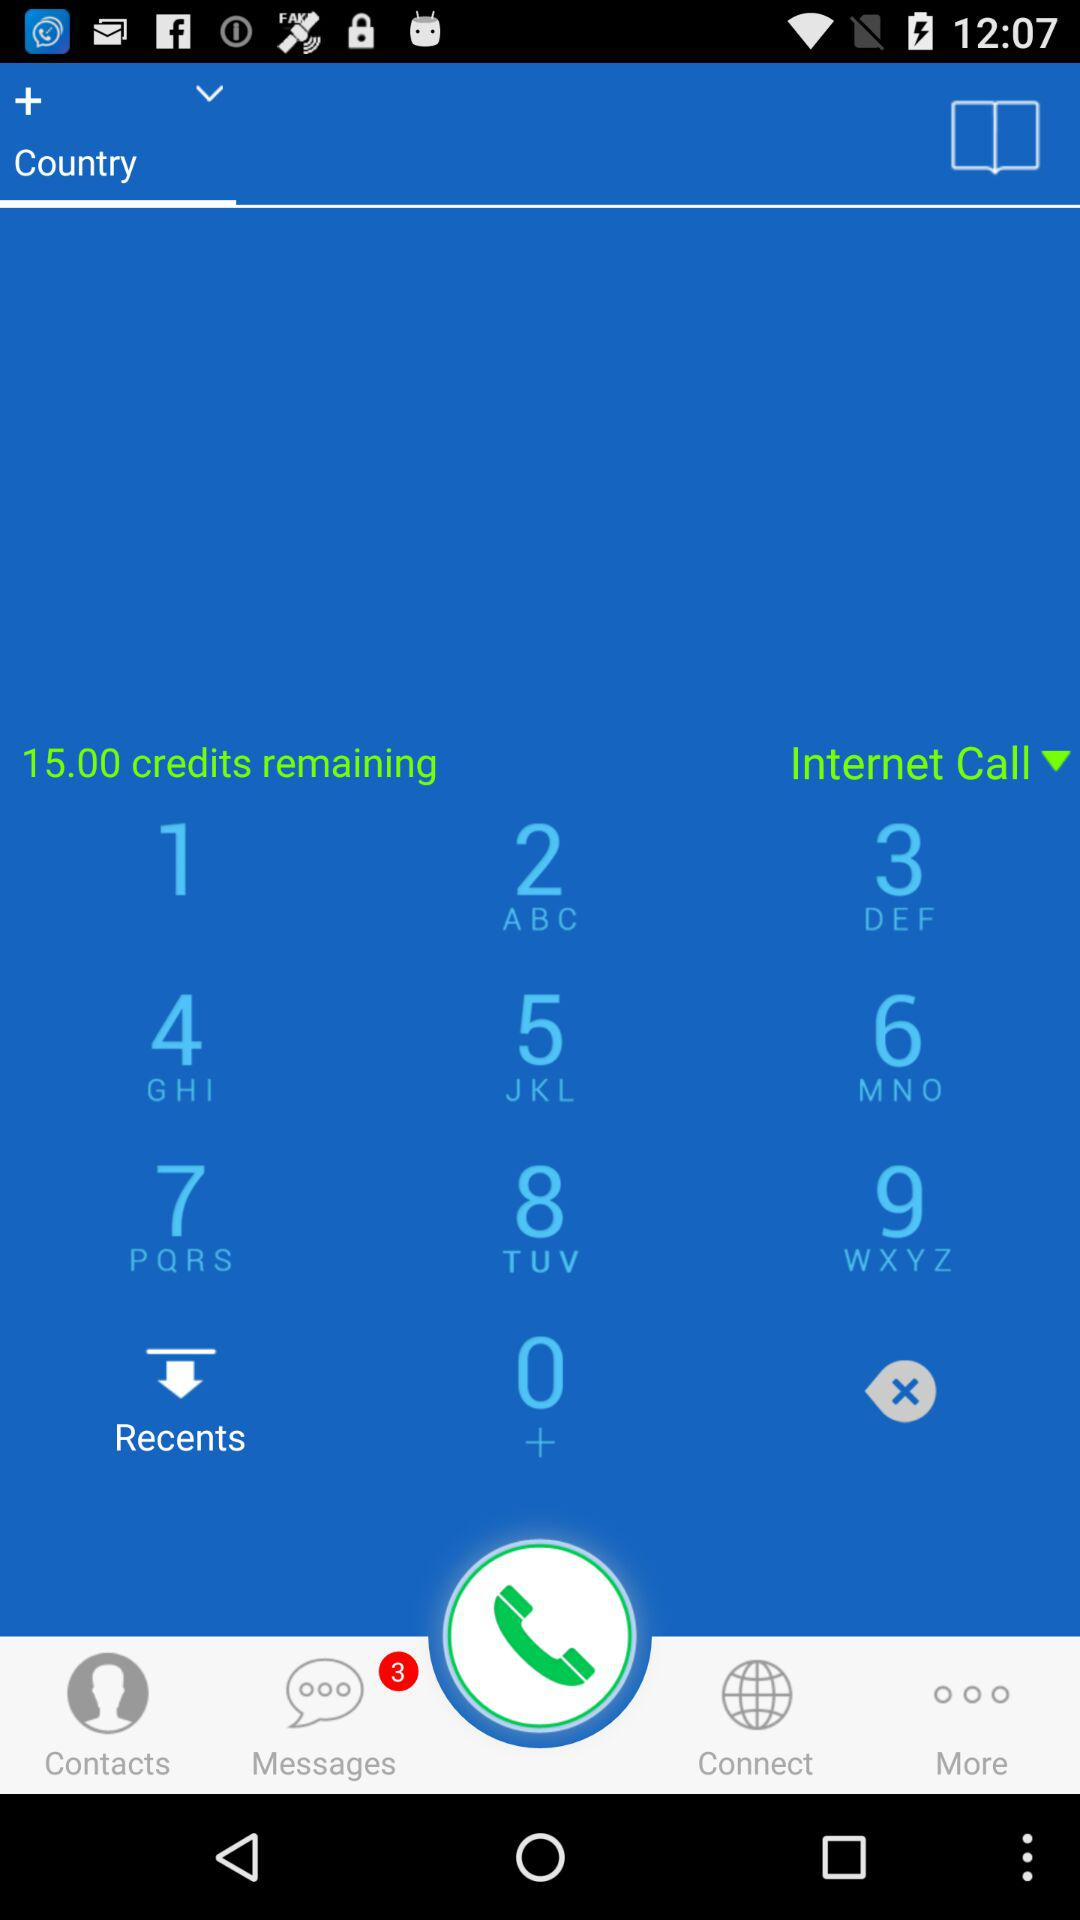How many more credits do I have than messages?
Answer the question using a single word or phrase. 12 